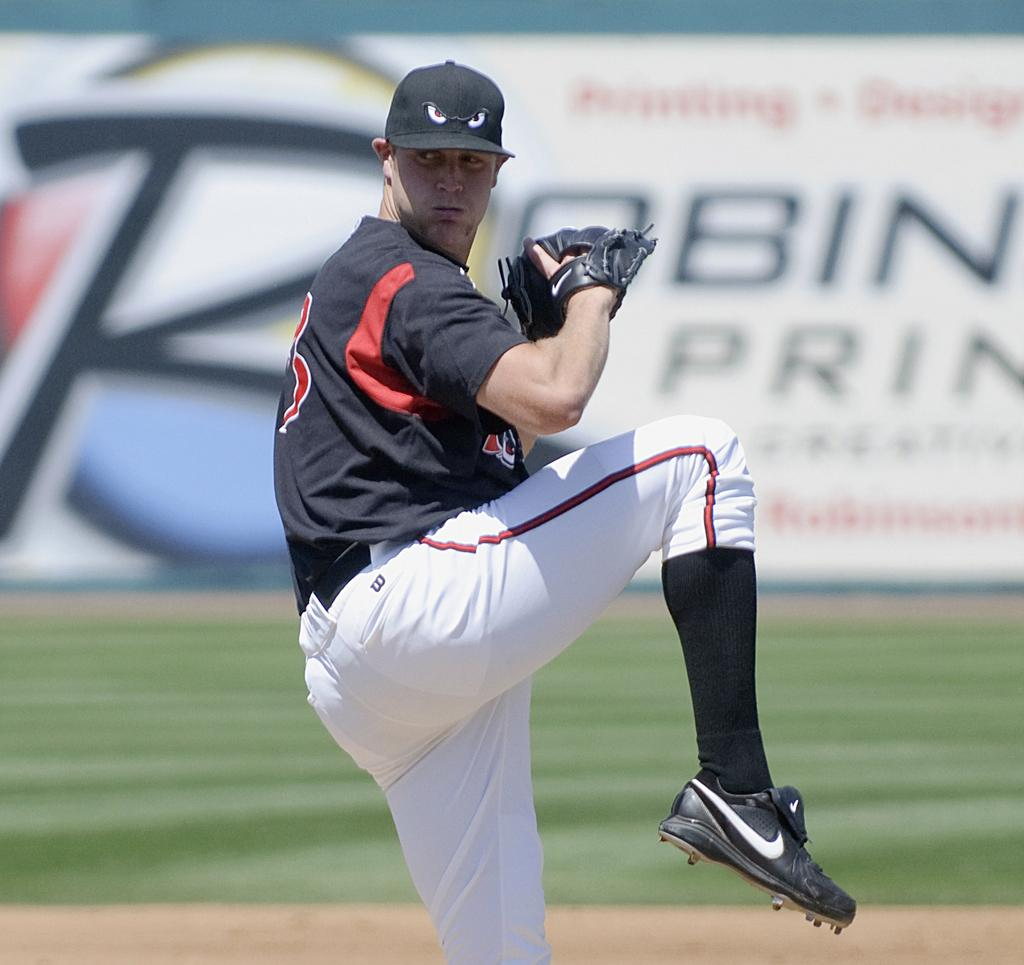Provide a one-sentence caption for the provided image. The pitcher has a small black W on his pants near the waistband. 